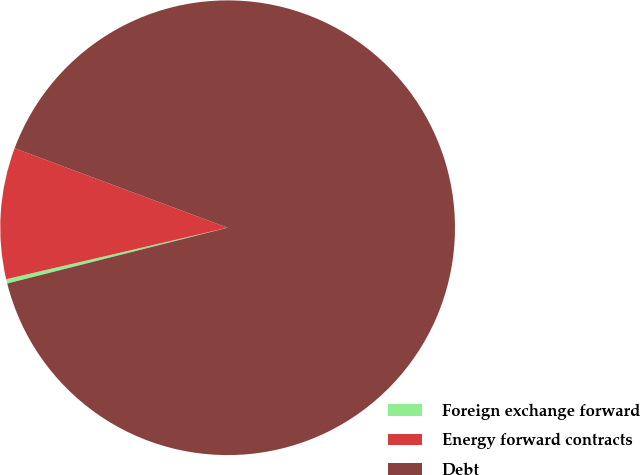Convert chart. <chart><loc_0><loc_0><loc_500><loc_500><pie_chart><fcel>Foreign exchange forward<fcel>Energy forward contracts<fcel>Debt<nl><fcel>0.31%<fcel>9.32%<fcel>90.37%<nl></chart> 